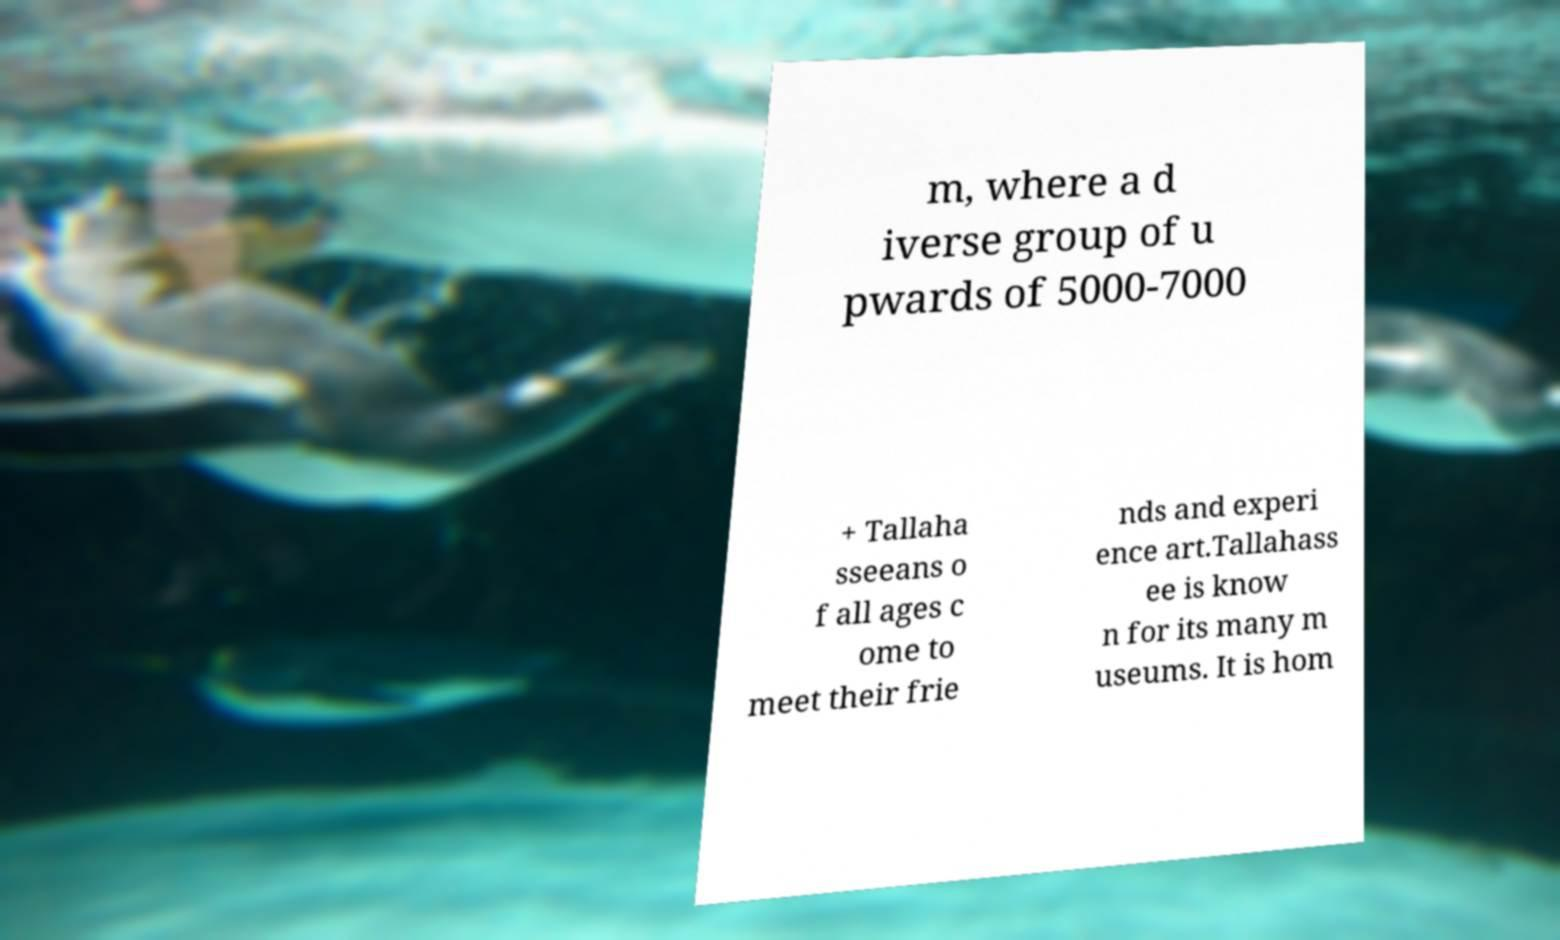Please read and relay the text visible in this image. What does it say? m, where a d iverse group of u pwards of 5000-7000 + Tallaha sseeans o f all ages c ome to meet their frie nds and experi ence art.Tallahass ee is know n for its many m useums. It is hom 